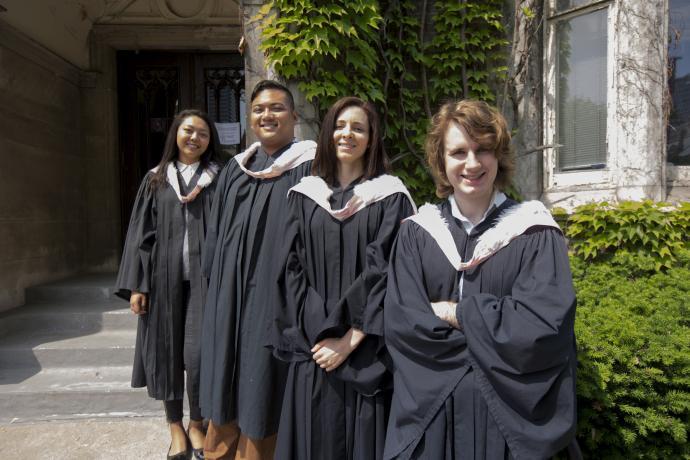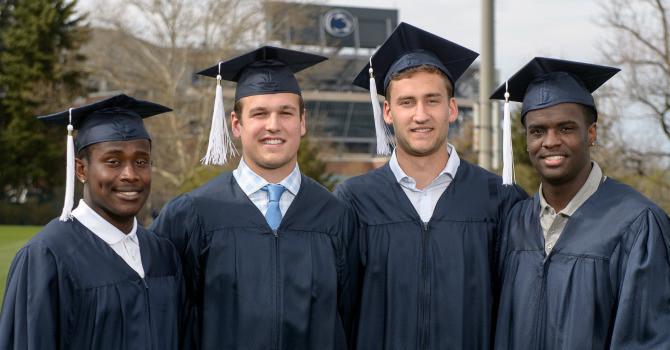The first image is the image on the left, the second image is the image on the right. Examine the images to the left and right. Is the description "The image on the left does not contain more than two people." accurate? Answer yes or no. No. The first image is the image on the left, the second image is the image on the right. Considering the images on both sides, is "There are two men with their shirts visible underneath there graduation gowns." valid? Answer yes or no. No. 